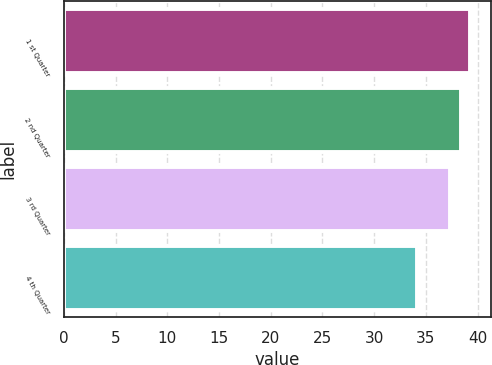Convert chart. <chart><loc_0><loc_0><loc_500><loc_500><bar_chart><fcel>1 st Quarter<fcel>2 nd Quarter<fcel>3 rd Quarter<fcel>4 th Quarter<nl><fcel>39.3<fcel>38.36<fcel>37.38<fcel>34.11<nl></chart> 